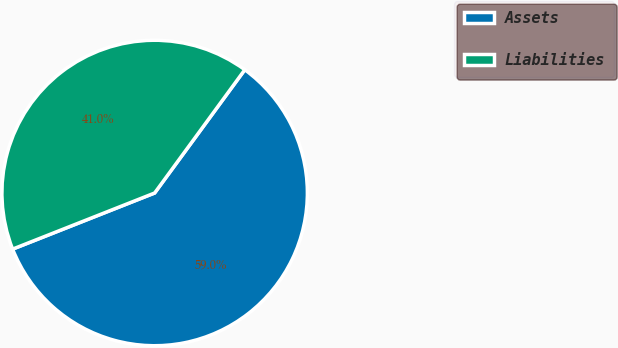<chart> <loc_0><loc_0><loc_500><loc_500><pie_chart><fcel>Assets<fcel>Liabilities<nl><fcel>58.96%<fcel>41.04%<nl></chart> 